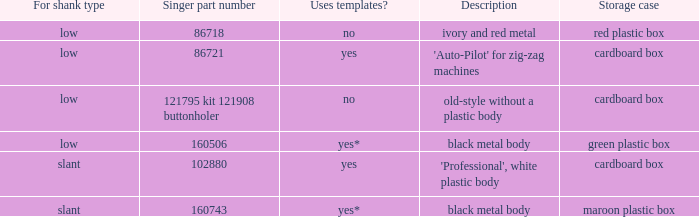What are all the distinct definitions for the buttonholer with a cardboard case for storage and a low shank kind? 'Auto-Pilot' for zig-zag machines, old-style without a plastic body. 